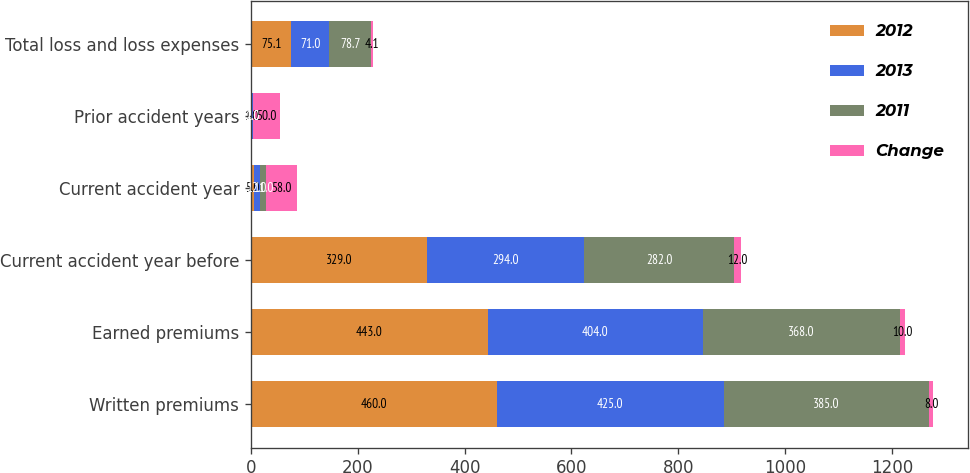Convert chart to OTSL. <chart><loc_0><loc_0><loc_500><loc_500><stacked_bar_chart><ecel><fcel>Written premiums<fcel>Earned premiums<fcel>Current accident year before<fcel>Current accident year<fcel>Prior accident years<fcel>Total loss and loss expenses<nl><fcel>2012<fcel>460<fcel>443<fcel>329<fcel>5<fcel>1<fcel>75.1<nl><fcel>2013<fcel>425<fcel>404<fcel>294<fcel>12<fcel>2<fcel>71<nl><fcel>2011<fcel>385<fcel>368<fcel>282<fcel>11<fcel>1<fcel>78.7<nl><fcel>Change<fcel>8<fcel>10<fcel>12<fcel>58<fcel>50<fcel>4.1<nl></chart> 